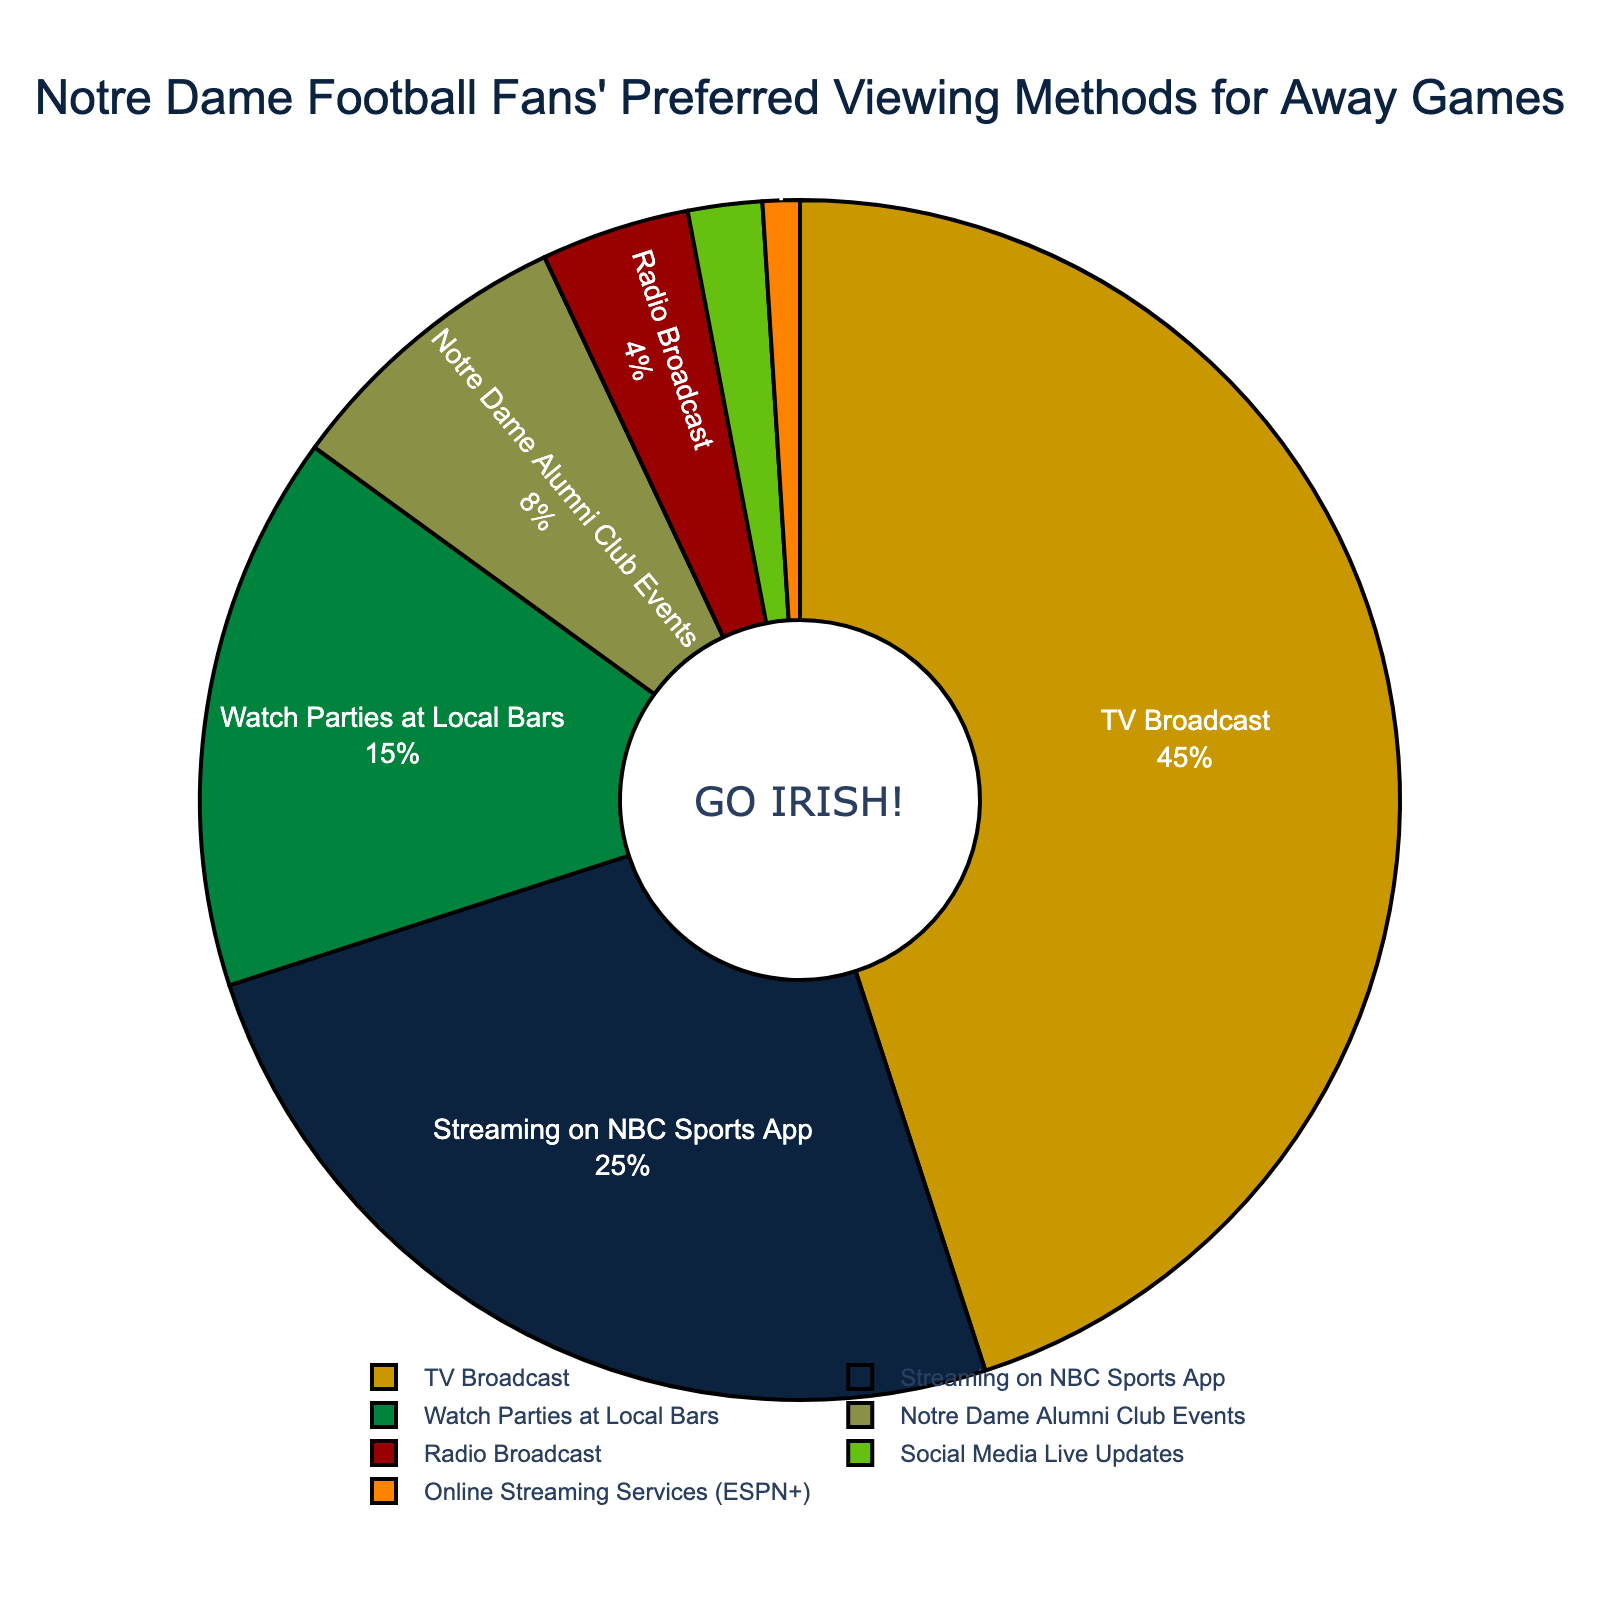What percentage of Notre Dame football fans prefer to watch away games via TV Broadcast? Look at the PIE segment labeled "TV Broadcast" and note the percentage value.
Answer: 45% What is the combined percentage of fans who prefer watching via Streaming on NBC Sports App and Watch Parties at Local Bars? Observe the PIE segments labeled "Streaming on NBC Sports App" and "Watch Parties at Local Bars," then sum their percentage values: 25% + 15%.
Answer: 40% Which viewing method has the least percentage of Notre Dame football fans? Identify the smallest PIE segment and its corresponding label, which is "Online Streaming Services (ESPN+)".
Answer: Online Streaming Services (ESPN+) How much higher is the percentage of fans preferring TV Broadcast over those preferring Radio Broadcast? Subtract the percentage of fans preferring Radio Broadcast (4%) from those preferring TV Broadcast (45%): 45% - 4%.
Answer: 41% Do more fans prefer Notre Dame Alumni Club Events or Watch Parties at Local Bars? Compare the PIE segments labeled "Notre Dame Alumni Club Events" (8%) and "Watch Parties at Local Bars" (15%), and see which segment is larger.
Answer: Watch Parties at Local Bars What is the sum of the percentages for fans who prefer Radio Broadcast and Social Media Live Updates? Add the percentages of "Radio Broadcast" (4%) and "Social Media Live Updates" (2%): 4% + 2%.
Answer: 6% Which two viewing methods together account for a quarter (25%) of the fans? Find two segments whose percentages add up to 25%. "Notre Dame Alumni Club Events" (8%) and "Watch Parties at Local Bars" (15%) together total 23%, and no other combination works.
Answer: None Which color represents the fans who watch Notre Dame away games on the NBC Sports App? Identify the color of the PIE segment labeled "Streaming on NBC Sports App".
Answer: Dark blue If you combine the percentages of the three smallest viewing methods, what is the total? Add the percentages of "Online Streaming Services (ESPN+)" (1%), "Social Media Live Updates" (2%), and "Radio Broadcast" (4%): 1% + 2% + 4%.
Answer: 7% How does the percentage of fans who tune into the TV Broadcast compare to those who attend Notre Dame Alumni Club Events? Subtract the percentage of "Notre Dame Alumni Club Events" (8%) from "TV Broadcast" (45%): 45% - 8%.
Answer: 37% 